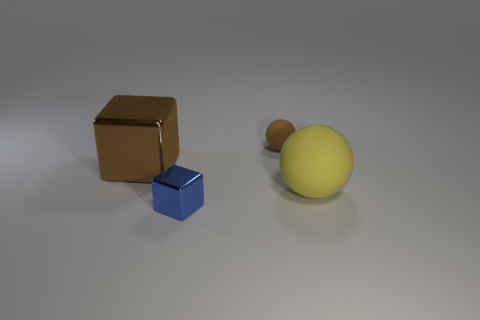What is the shape of the thing that is behind the large matte object and in front of the small brown rubber object?
Your response must be concise. Cube. How many other objects are there of the same shape as the big shiny thing?
Ensure brevity in your answer.  1. The matte object that is behind the object to the right of the brown object that is on the right side of the tiny blue shiny block is what shape?
Your response must be concise. Sphere. How many things are either brown matte spheres or tiny things behind the brown block?
Provide a succinct answer. 1. There is a small thing in front of the large yellow rubber object; does it have the same shape as the metallic object behind the big yellow ball?
Ensure brevity in your answer.  Yes. What number of objects are either big yellow matte blocks or brown objects?
Keep it short and to the point. 2. Are any yellow shiny things visible?
Offer a terse response. No. Do the big thing that is on the left side of the yellow thing and the yellow thing have the same material?
Offer a terse response. No. Is there a purple shiny thing that has the same shape as the small blue object?
Give a very brief answer. No. Are there an equal number of large yellow matte things left of the large rubber sphere and big brown metal objects?
Make the answer very short. No. 